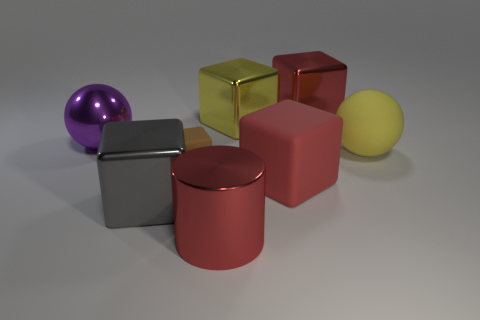Is there anything else that is the same size as the brown matte object?
Offer a very short reply. No. The red metal object that is in front of the metallic cube that is in front of the small brown thing is what shape?
Keep it short and to the point. Cylinder. Are there any large red objects made of the same material as the big gray object?
Offer a terse response. Yes. Do the purple metal object that is left of the red metal block and the gray metallic object have the same size?
Your answer should be compact. Yes. What number of red things are rubber blocks or large cubes?
Offer a very short reply. 2. What is the material of the sphere that is on the right side of the large red shiny cube?
Provide a succinct answer. Rubber. What number of large gray metallic objects are on the right side of the big ball that is on the right side of the large purple ball?
Give a very brief answer. 0. How many red shiny objects have the same shape as the yellow matte thing?
Ensure brevity in your answer.  0. What number of large red metallic cylinders are there?
Provide a short and direct response. 1. There is a big metal cube that is in front of the shiny ball; what color is it?
Provide a short and direct response. Gray. 